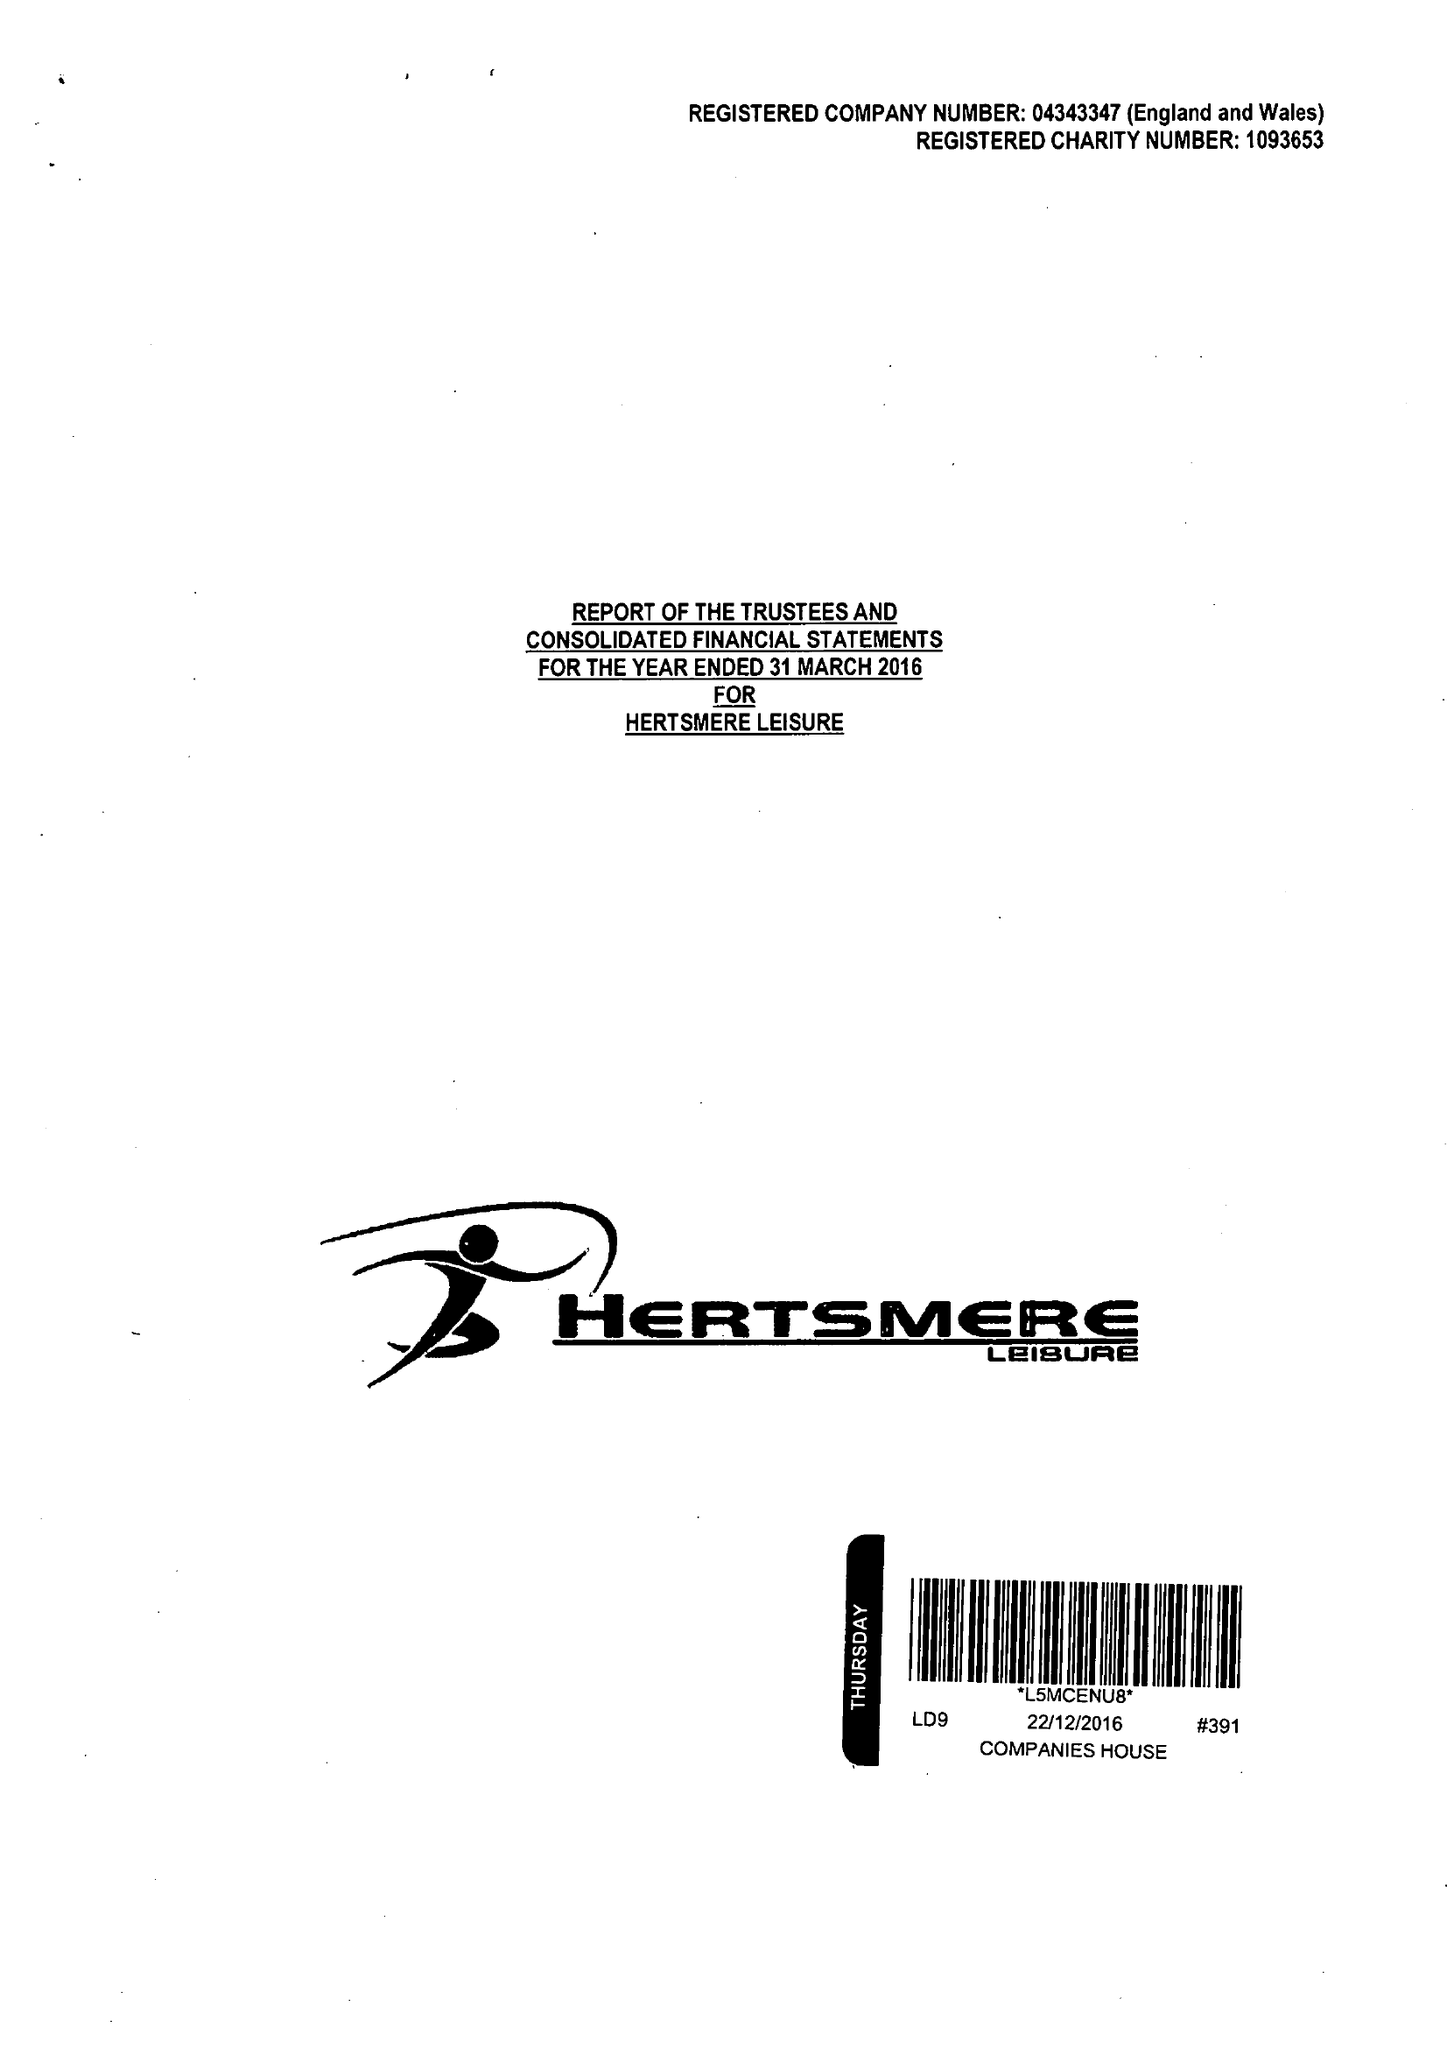What is the value for the charity_number?
Answer the question using a single word or phrase. 1093653 